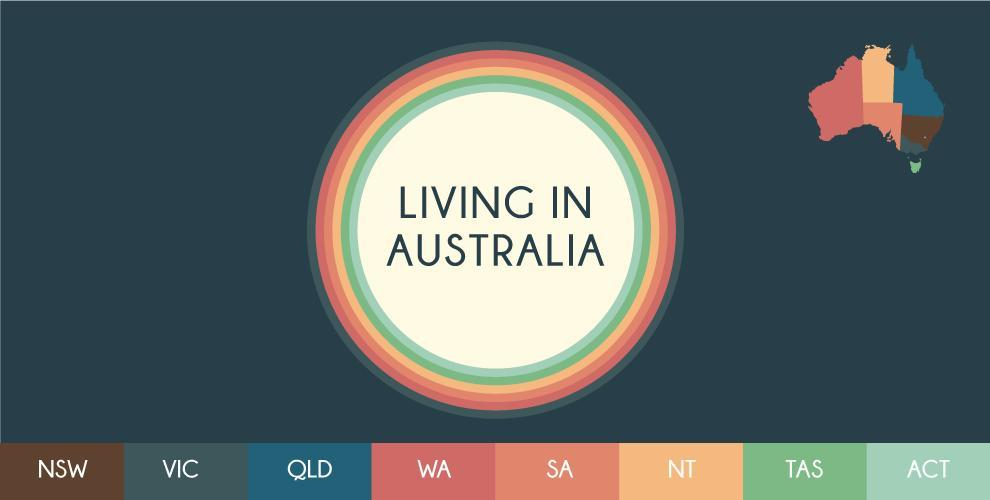How many states are there in Australia?
Answer the question with a short phrase. 8 